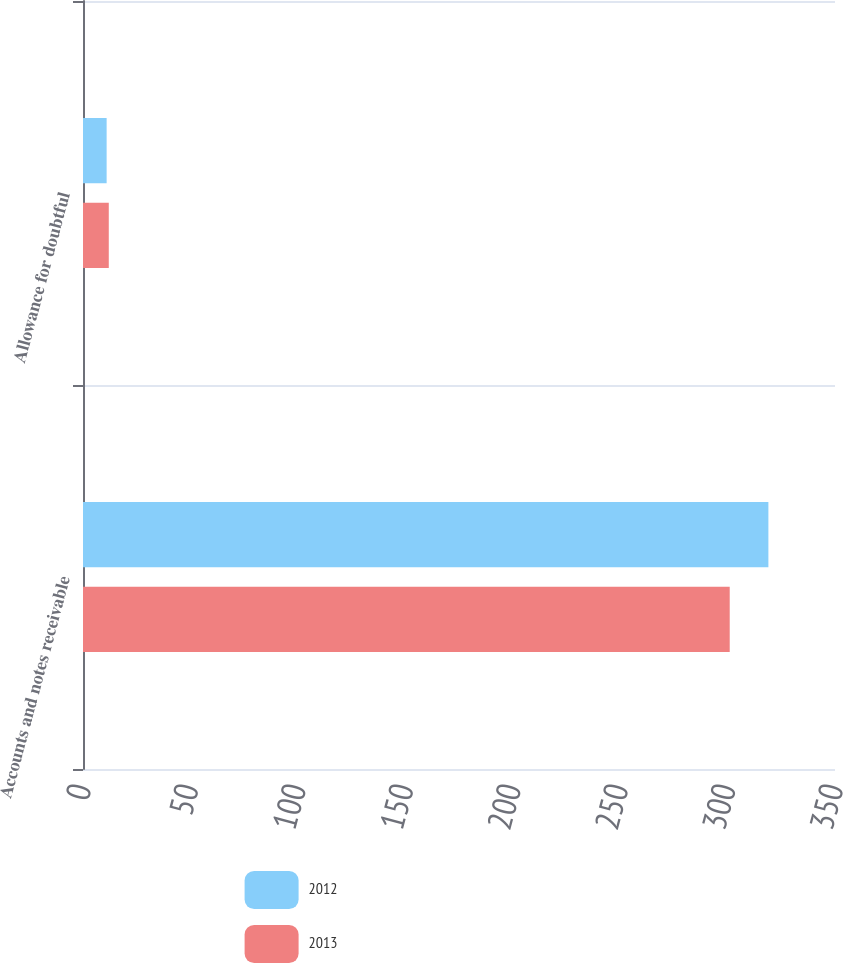Convert chart. <chart><loc_0><loc_0><loc_500><loc_500><stacked_bar_chart><ecel><fcel>Accounts and notes receivable<fcel>Allowance for doubtful<nl><fcel>2012<fcel>319<fcel>11<nl><fcel>2013<fcel>301<fcel>12<nl></chart> 